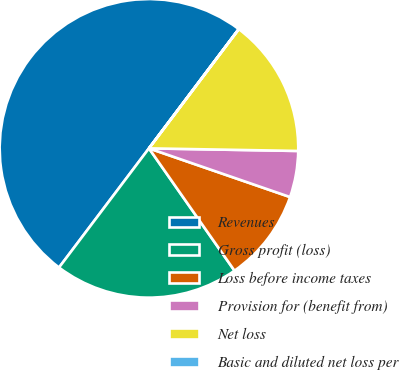Convert chart. <chart><loc_0><loc_0><loc_500><loc_500><pie_chart><fcel>Revenues<fcel>Gross profit (loss)<fcel>Loss before income taxes<fcel>Provision for (benefit from)<fcel>Net loss<fcel>Basic and diluted net loss per<nl><fcel>49.98%<fcel>20.0%<fcel>10.0%<fcel>5.01%<fcel>15.0%<fcel>0.01%<nl></chart> 